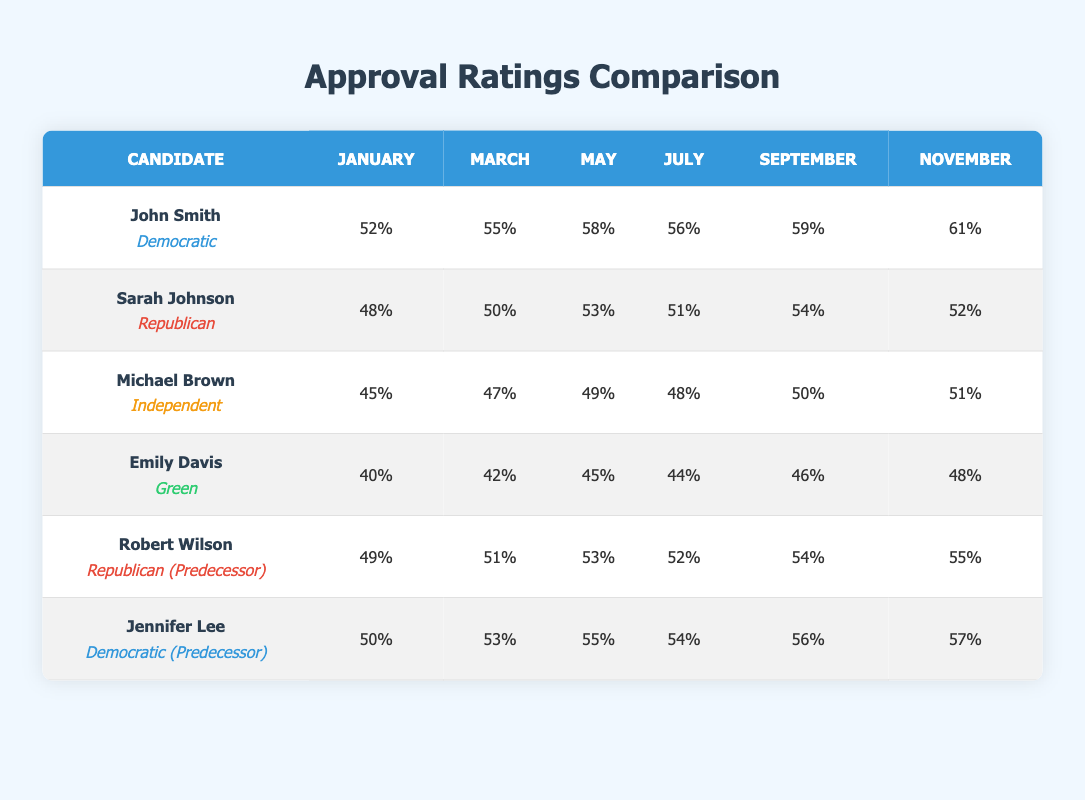What are the highest approval ratings achieved by John Smith? From the table, the highest approval rating for John Smith occurs in November, where his rating is 61%.
Answer: 61% What was Sarah Johnson's approval rating in March? Referring to the table, Sarah Johnson's approval rating in March is 50%.
Answer: 50% Which candidate had an approval rating above 50% in September? Looking at the September ratings, John Smith (59%) and Robert Wilson (54%) both had ratings above 50%.
Answer: John Smith and Robert Wilson What is the average approval rating for Emily Davis over the six months? To find the average, sum Emily Davis's ratings (40 + 42 + 45 + 44 + 46 + 48) = 265, then divide by 6, giving an average of 265 / 6 ≈ 44.17.
Answer: 44.17 Did any candidate maintain consistent growth in their approval ratings throughout the months? By examining the table, John Smith shows an increasing trend from January to November. His ratings rise from 52% to 61%.
Answer: Yes, John Smith What is the difference between the highest and lowest approval rating for Michael Brown? Michael Brown's highest rating is 51% (November) and his lowest is 45% (January). The difference is 51 - 45 = 6%.
Answer: 6% Which candidate had a higher average rating: John Smith or Robert Wilson? John Smith's average rating totals (52 + 55 + 58 + 56 + 59 + 61 = 341) / 6 = 56.83%, whereas Robert Wilson's ratings sum to (49 + 51 + 53 + 52 + 54 + 55 = 314) / 6 = 52.33%. Since 56.83% > 52.33%, John Smith has a higher average.
Answer: John Smith Is it true that Jennifer Lee had a higher approval rating than Sarah Johnson in all months? To confirm, we can compare their ratings month by month: January (50 vs. 48), March (53 vs. 50), May (55 vs. 53), July (54 vs. 51), September (56 vs. 54), November (57 vs. 52). In all months, Jennifer Lee has higher ratings than Sarah Johnson, confirming the statement is true.
Answer: Yes, true What was the total approval rating for all candidates in July? The July ratings are: John Smith (56) + Sarah Johnson (51) + Michael Brown (48) + Emily Davis (44) + Robert Wilson (52) + Jennifer Lee (54) = 56 + 51 + 48 + 44 + 52 + 54 = 305.
Answer: 305 